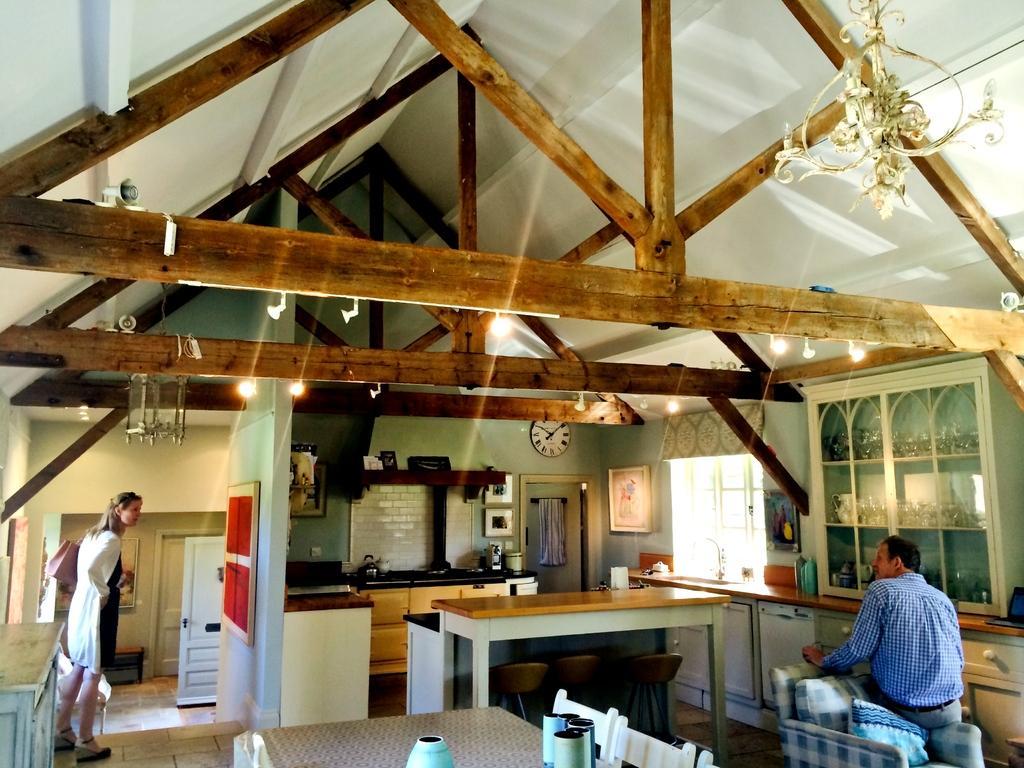Can you describe this image briefly? In this picture there is a person sitting on the couch and there is a woman standing over here there is a wall clock fixed on wall over here and there some chairs here is the crockery place here and there are some lights and was here 